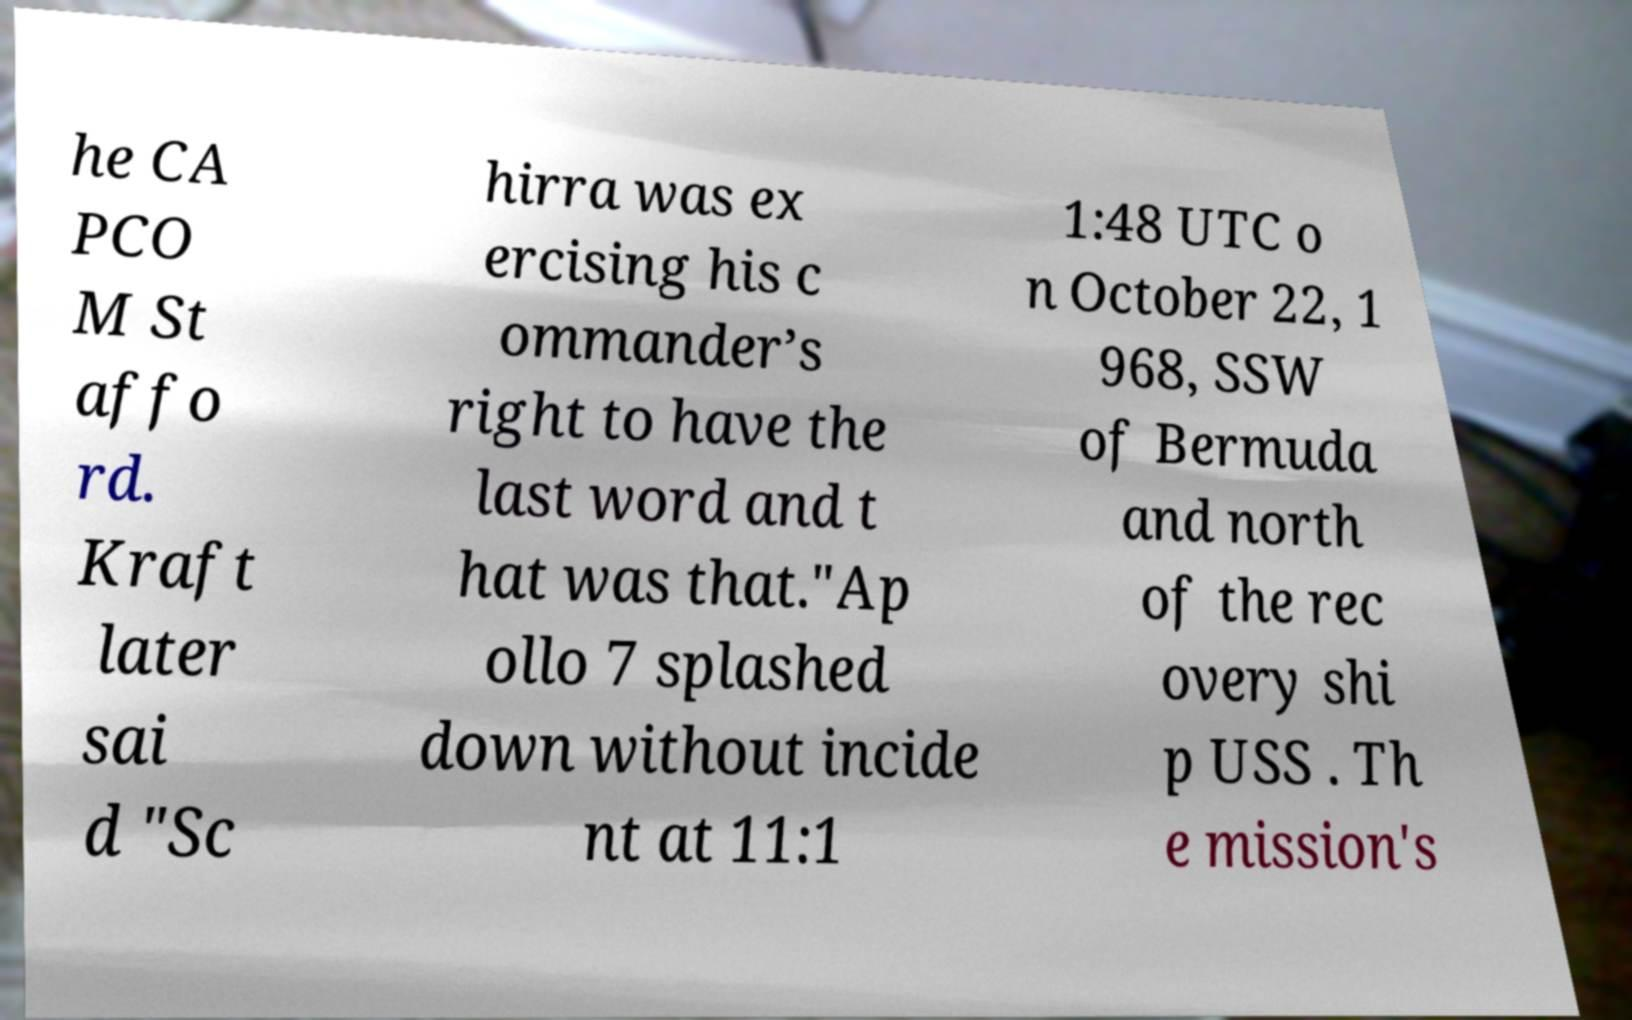Could you extract and type out the text from this image? he CA PCO M St affo rd. Kraft later sai d "Sc hirra was ex ercising his c ommander’s right to have the last word and t hat was that."Ap ollo 7 splashed down without incide nt at 11:1 1:48 UTC o n October 22, 1 968, SSW of Bermuda and north of the rec overy shi p USS . Th e mission's 